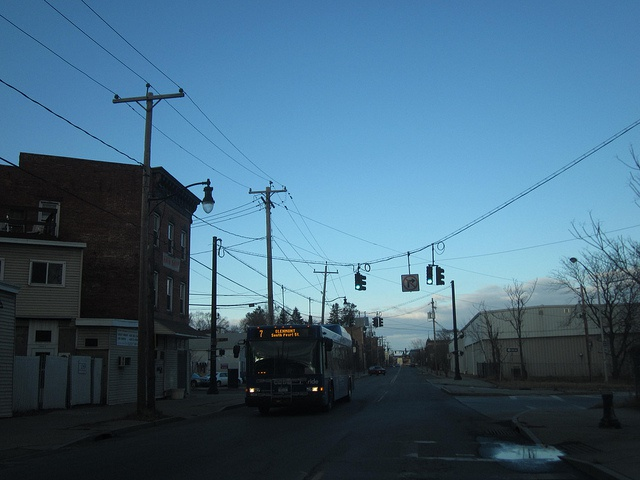Describe the objects in this image and their specific colors. I can see bus in teal, black, gray, darkblue, and blue tones, car in teal, black, blue, and darkblue tones, car in black, darkblue, blue, and teal tones, traffic light in teal, black, lightblue, and darkblue tones, and traffic light in teal, black, navy, and blue tones in this image. 